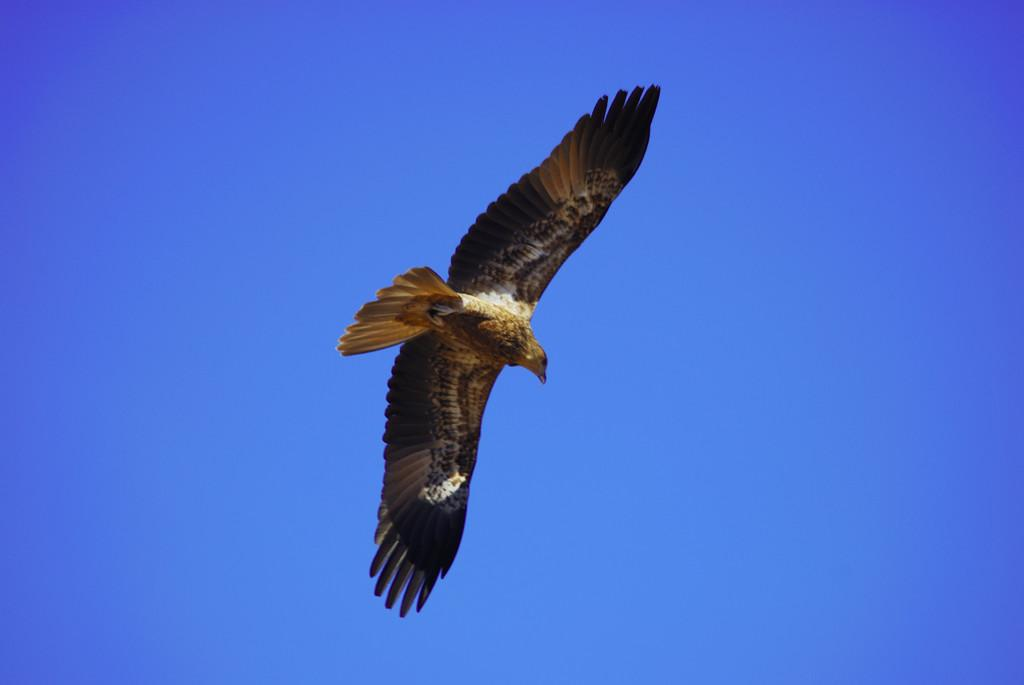What type of animal can be seen in the image? There is a bird in the image. What is the bird doing in the image? The bird is flying. What can be seen in the background of the image? The background of the image appears to be the sky. What color is the sky in the image? The sky is blue in color. What type of plastic is the bird holding in the image? There is no plastic present in the image, and the bird is not holding anything. 